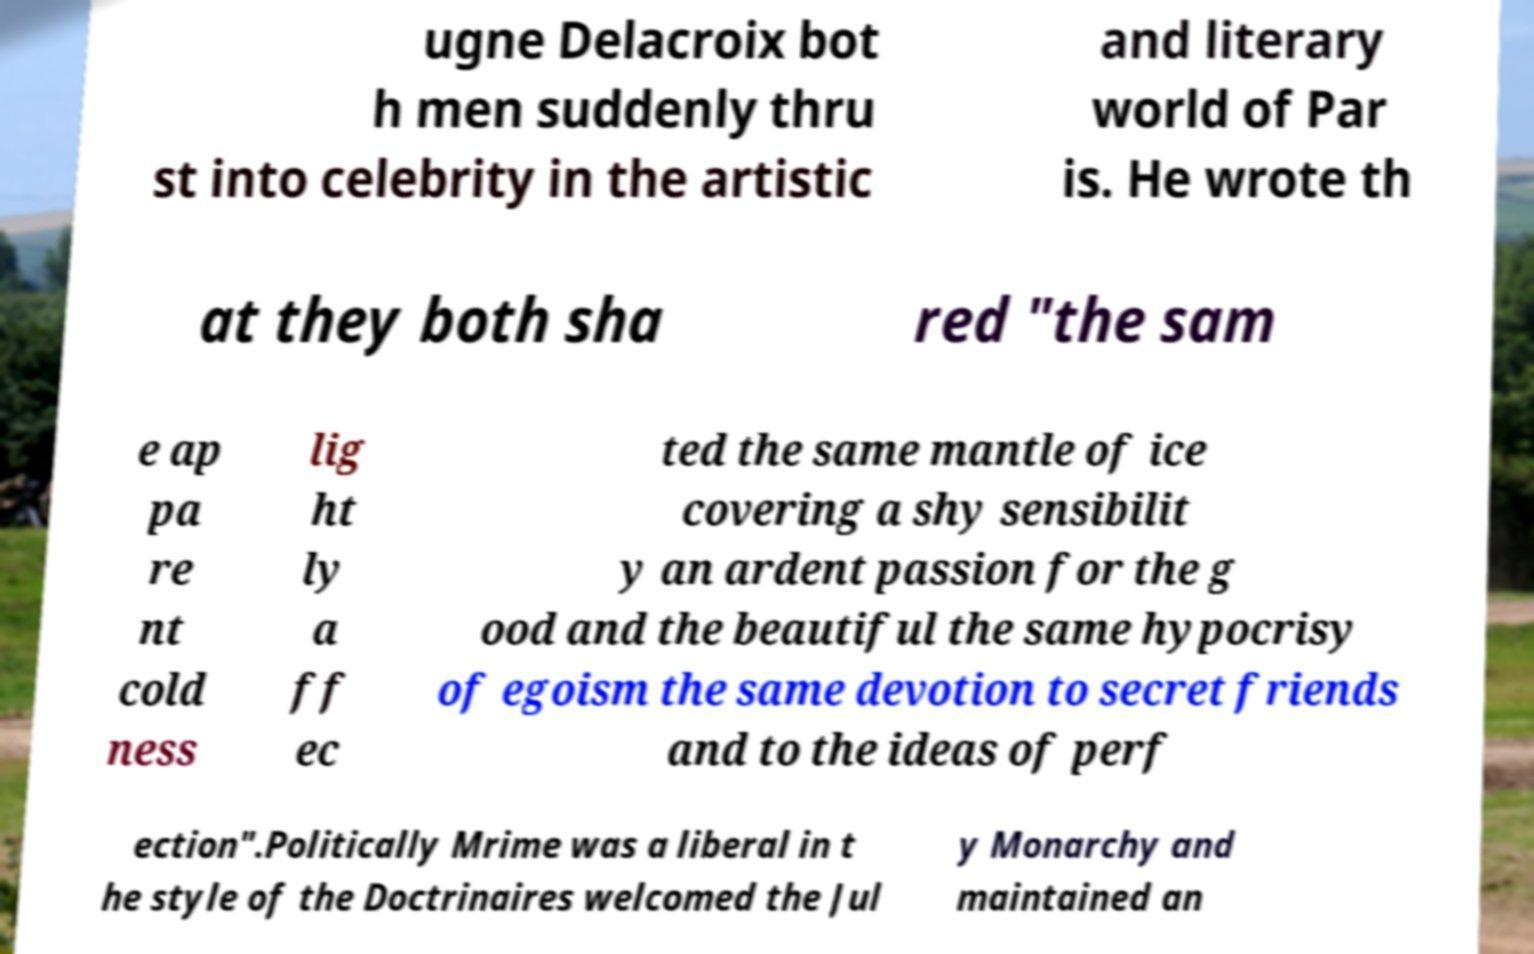Can you accurately transcribe the text from the provided image for me? ugne Delacroix bot h men suddenly thru st into celebrity in the artistic and literary world of Par is. He wrote th at they both sha red "the sam e ap pa re nt cold ness lig ht ly a ff ec ted the same mantle of ice covering a shy sensibilit y an ardent passion for the g ood and the beautiful the same hypocrisy of egoism the same devotion to secret friends and to the ideas of perf ection".Politically Mrime was a liberal in t he style of the Doctrinaires welcomed the Jul y Monarchy and maintained an 